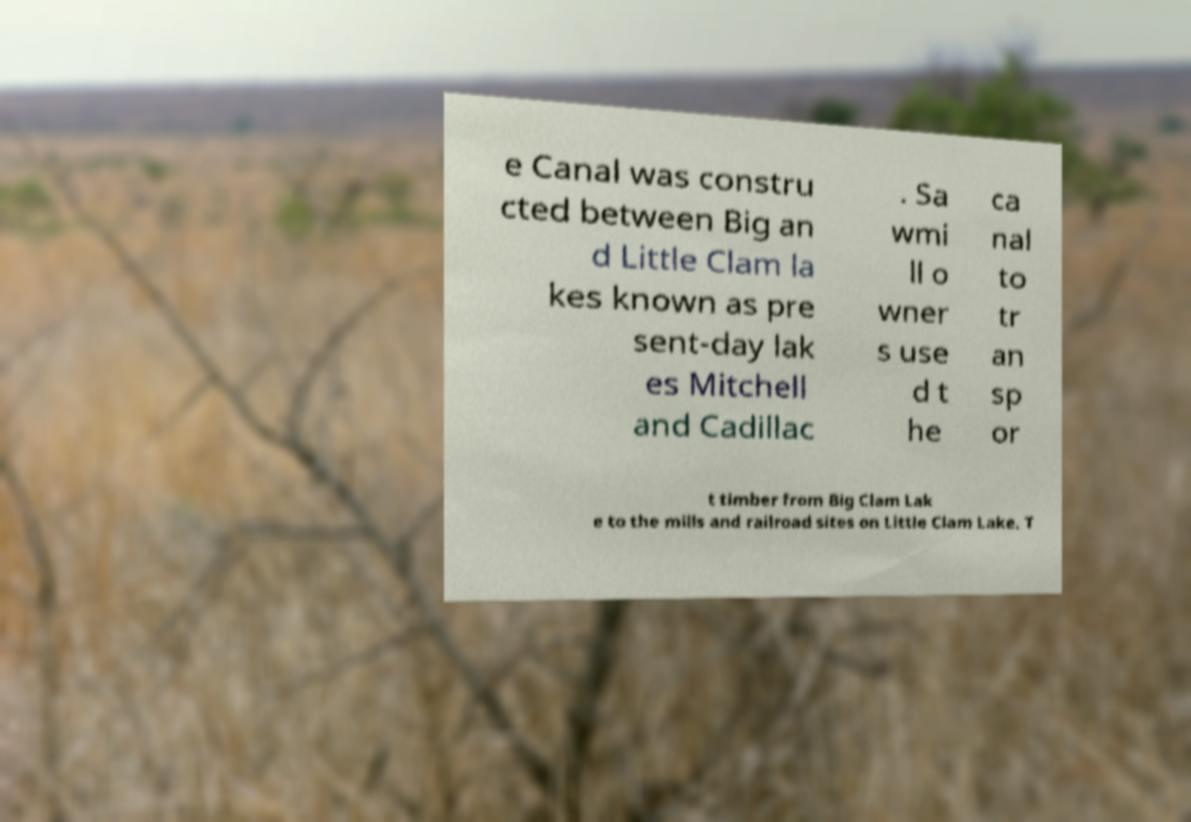I need the written content from this picture converted into text. Can you do that? e Canal was constru cted between Big an d Little Clam la kes known as pre sent-day lak es Mitchell and Cadillac . Sa wmi ll o wner s use d t he ca nal to tr an sp or t timber from Big Clam Lak e to the mills and railroad sites on Little Clam Lake. T 